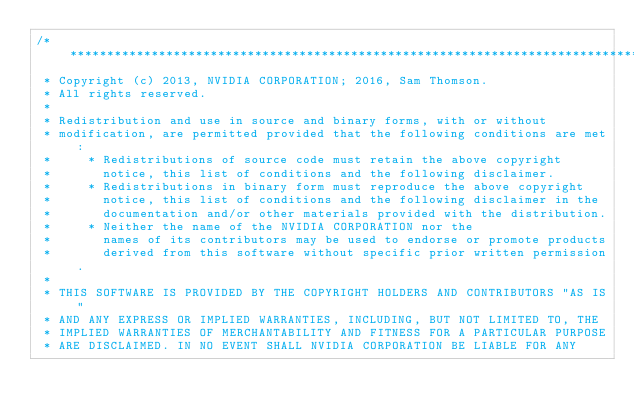<code> <loc_0><loc_0><loc_500><loc_500><_Cuda_>/******************************************************************************
 * Copyright (c) 2013, NVIDIA CORPORATION; 2016, Sam Thomson.
 * All rights reserved.
 *
 * Redistribution and use in source and binary forms, with or without
 * modification, are permitted provided that the following conditions are met:
 *     * Redistributions of source code must retain the above copyright
 *       notice, this list of conditions and the following disclaimer.
 *     * Redistributions in binary form must reproduce the above copyright
 *       notice, this list of conditions and the following disclaimer in the
 *       documentation and/or other materials provided with the distribution.
 *     * Neither the name of the NVIDIA CORPORATION nor the
 *       names of its contributors may be used to endorse or promote products
 *       derived from this software without specific prior written permission.
 *
 * THIS SOFTWARE IS PROVIDED BY THE COPYRIGHT HOLDERS AND CONTRIBUTORS "AS IS"
 * AND ANY EXPRESS OR IMPLIED WARRANTIES, INCLUDING, BUT NOT LIMITED TO, THE
 * IMPLIED WARRANTIES OF MERCHANTABILITY AND FITNESS FOR A PARTICULAR PURPOSE
 * ARE DISCLAIMED. IN NO EVENT SHALL NVIDIA CORPORATION BE LIABLE FOR ANY</code> 